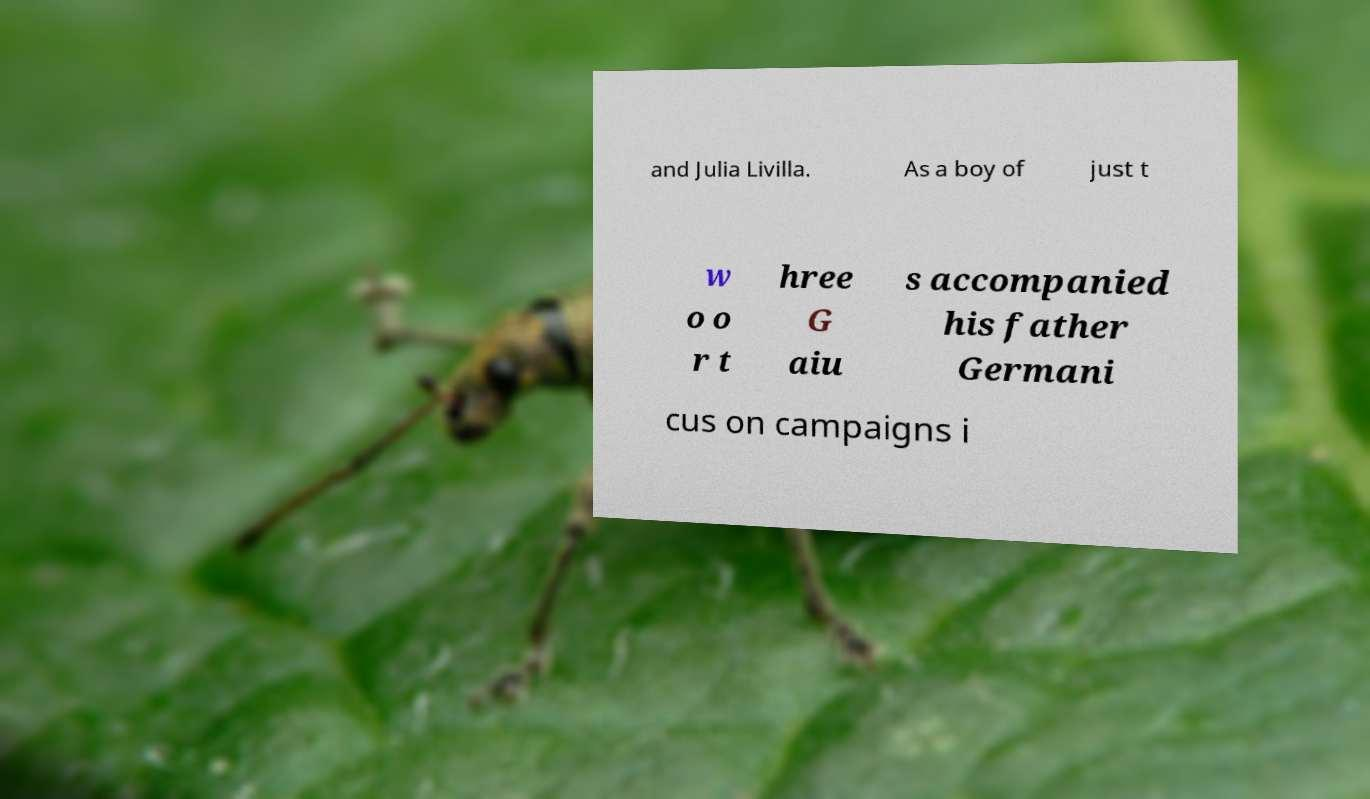What messages or text are displayed in this image? I need them in a readable, typed format. and Julia Livilla. As a boy of just t w o o r t hree G aiu s accompanied his father Germani cus on campaigns i 